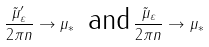Convert formula to latex. <formula><loc_0><loc_0><loc_500><loc_500>\frac { \tilde { \mu } _ { \varepsilon } ^ { \prime } } { 2 \pi n } \rightarrow \mu _ { * } \, \text { and} \, \frac { \tilde { \mu } _ { \varepsilon } } { 2 \pi n } \rightarrow \mu _ { * }</formula> 